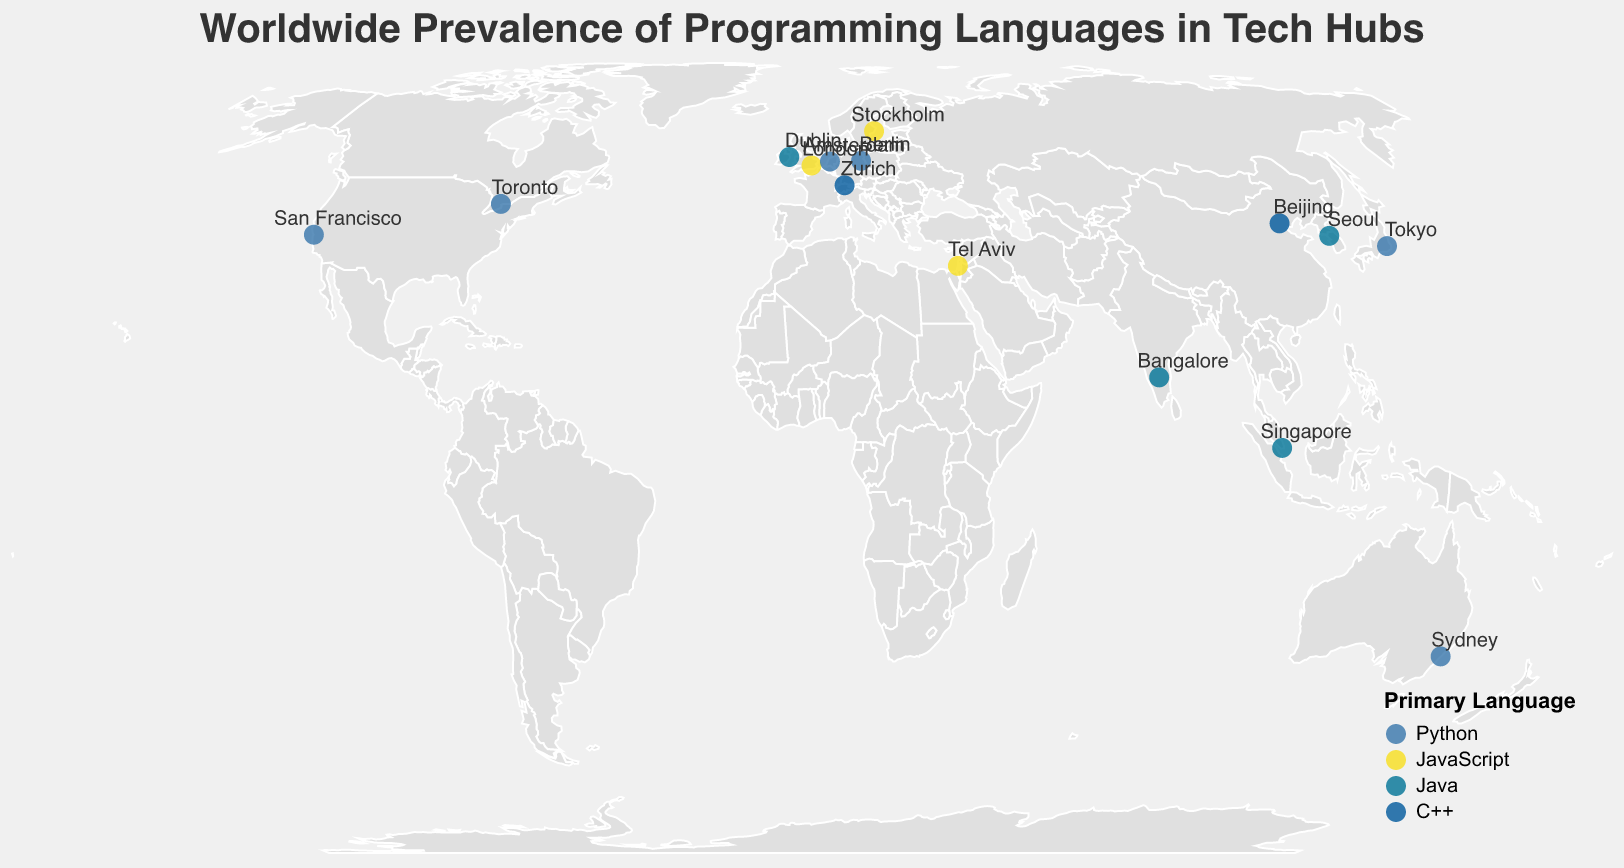What is the primary programming language most frequently used in listed tech hubs? The plot shows tech hubs with primary programming languages indicated by color. Python appears most frequently across various cities like San Francisco, Berlin, Tokyo, Toronto, etc.
Answer: Python Which tech hub has C++ as the primary programming language? The plot shows markers with primary languages indicated by color and labels for cities. Beijing and Zurich have C++ as the primary language.
Answer: Beijing and Zurich In how many tech hubs is JavaScript the primary language? By counting the cities with markers colored to represent JavaScript as the primary language, we identify London, Tel Aviv, Stockholm, and San Francisco.
Answer: 4 Which city in Australia is shown on the plot, and what is its primary programming language? By checking the city labels and looking for the city in Australia, we find Sydney. Its marker color indicates the primary language is Python.
Answer: Sydney, Python Compare the primary programming languages of Tel Aviv and Berlin. Which one uses JavaScript primarily? The plot shows Tel Aviv with a marker for JavaScript primary language, while Berlin shows Python.
Answer: Tel Aviv How many cities include JavaScript either as a primary, secondary, or tertiary language? By examining the plot for cities with JavaScript in any of the three categories, we find San Francisco, Bangalore, London, Berlin, Tel Aviv, Stockholm, Toronto, Singapore, Amsterdam, Dublin, and Sydney.
Answer: 11 What is the secondary programming language in Tokyo, and which city also shares this as a primary language? According to the plot's tooltip, Tokyo's secondary language is Java, which is also the primary language in Bangalore, Singapore, Dublin, and Seoul.
Answer: Java, Bangalore/Singapore/Dublin/Seoul Which cities have Java as their primary programming language? By looking at the plot, the cities with markers indicating Java as the primary language are Bangalore, Singapore, Dublin, and Seoul.
Answer: Bangalore, Singapore, Dublin, and Seoul What primary programming language do San Francisco and Sydney share? The plot shows that both San Francisco and Sydney have markers colored to indicate Python as the primary programming language.
Answer: Python In terms of the prevalence of programming languages, does any city in the plot use Ruby? If so, which city is it? Upon checking the tooltips and markers on the plot, Tokyo is the city that lists Ruby as a tertiary language.
Answer: Tokyo 